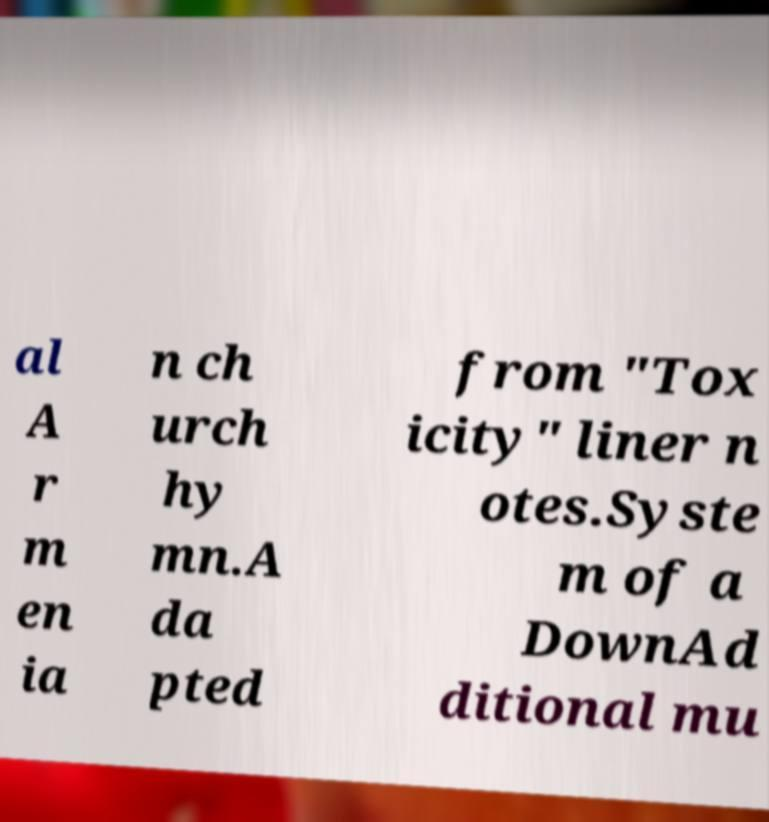I need the written content from this picture converted into text. Can you do that? al A r m en ia n ch urch hy mn.A da pted from "Tox icity" liner n otes.Syste m of a DownAd ditional mu 